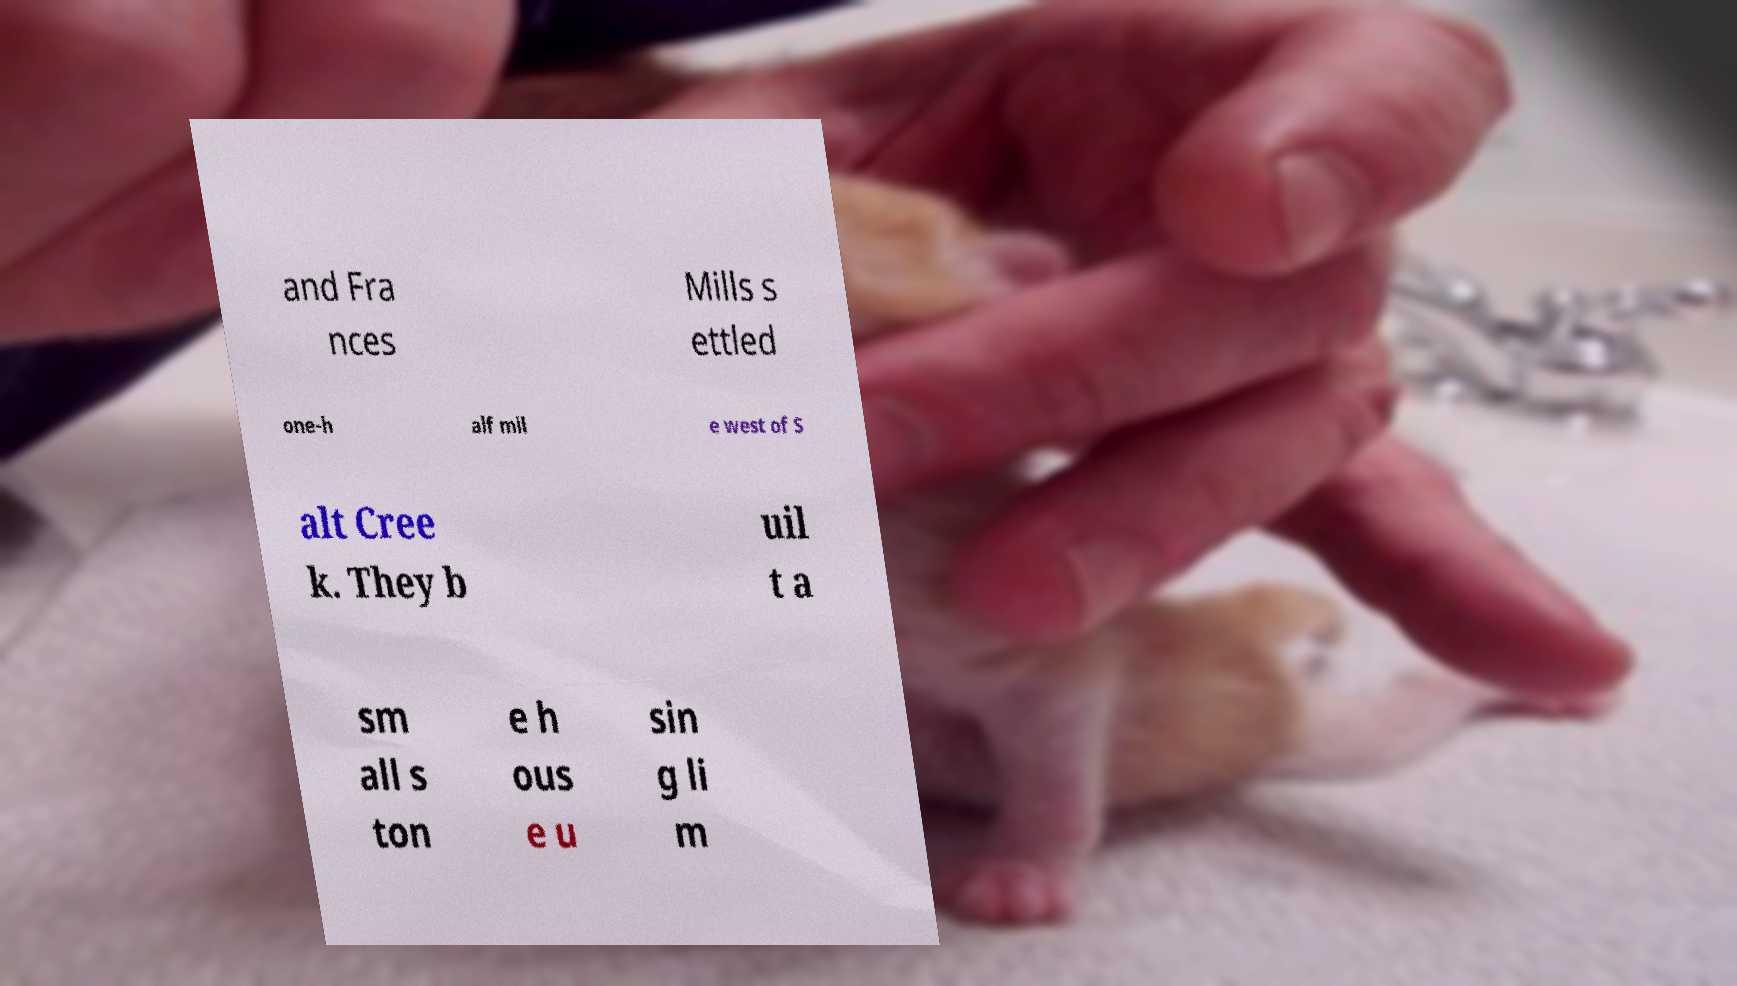Could you extract and type out the text from this image? and Fra nces Mills s ettled one-h alf mil e west of S alt Cree k. They b uil t a sm all s ton e h ous e u sin g li m 